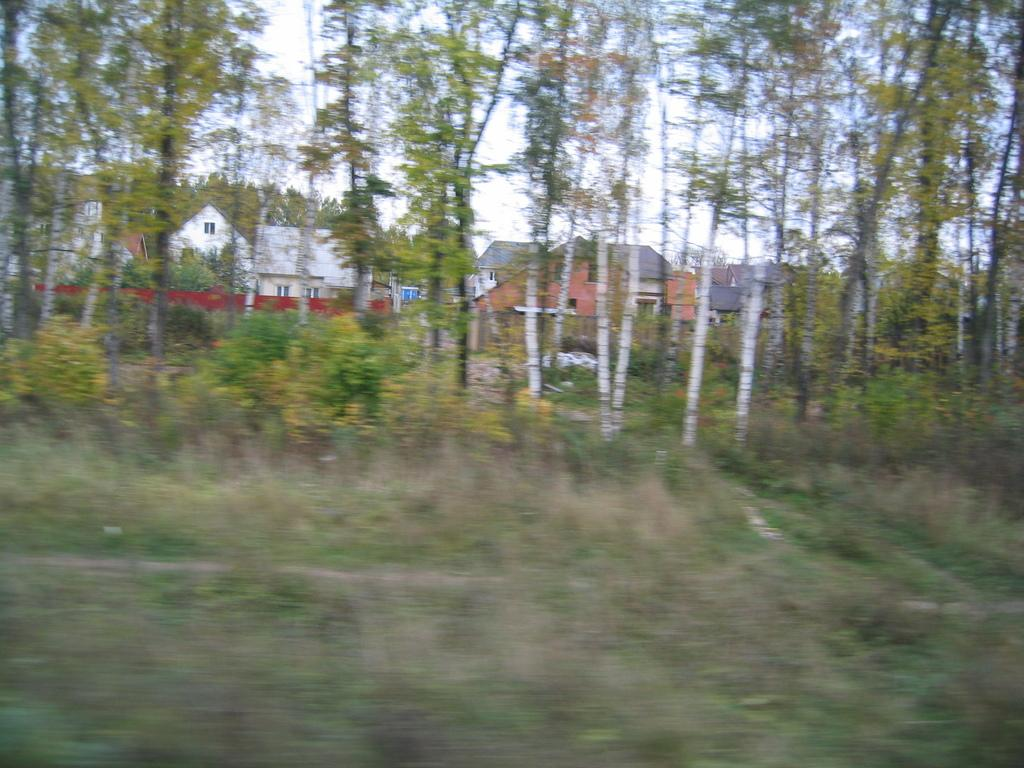What type of natural elements can be seen in the image? There are plants and trees in the image. What type of man-made structures are visible in the image? There are houses in the image. What part of the natural environment is visible in the image? The sky is visible in the image. What type of dirt can be seen on the paper in the image? There is no paper or dirt present in the image. 